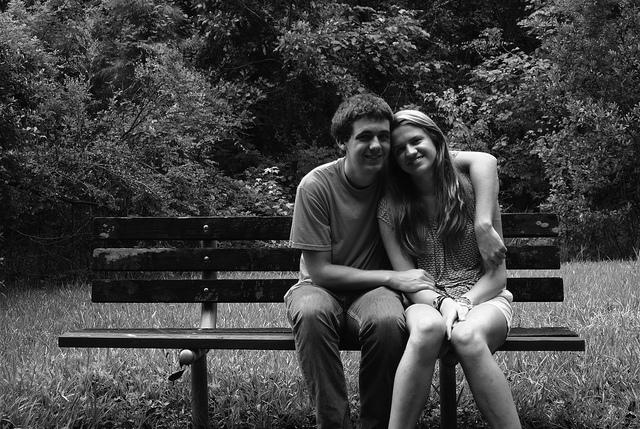Where is the man's left arm?
Be succinct. Around girl. What is the couple sitting on?
Short answer required. Bench. Is this couple over 20 years old?
Answer briefly. No. 